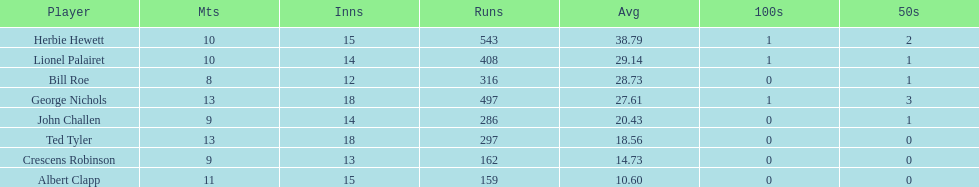How many more runs does john have than albert? 127. 